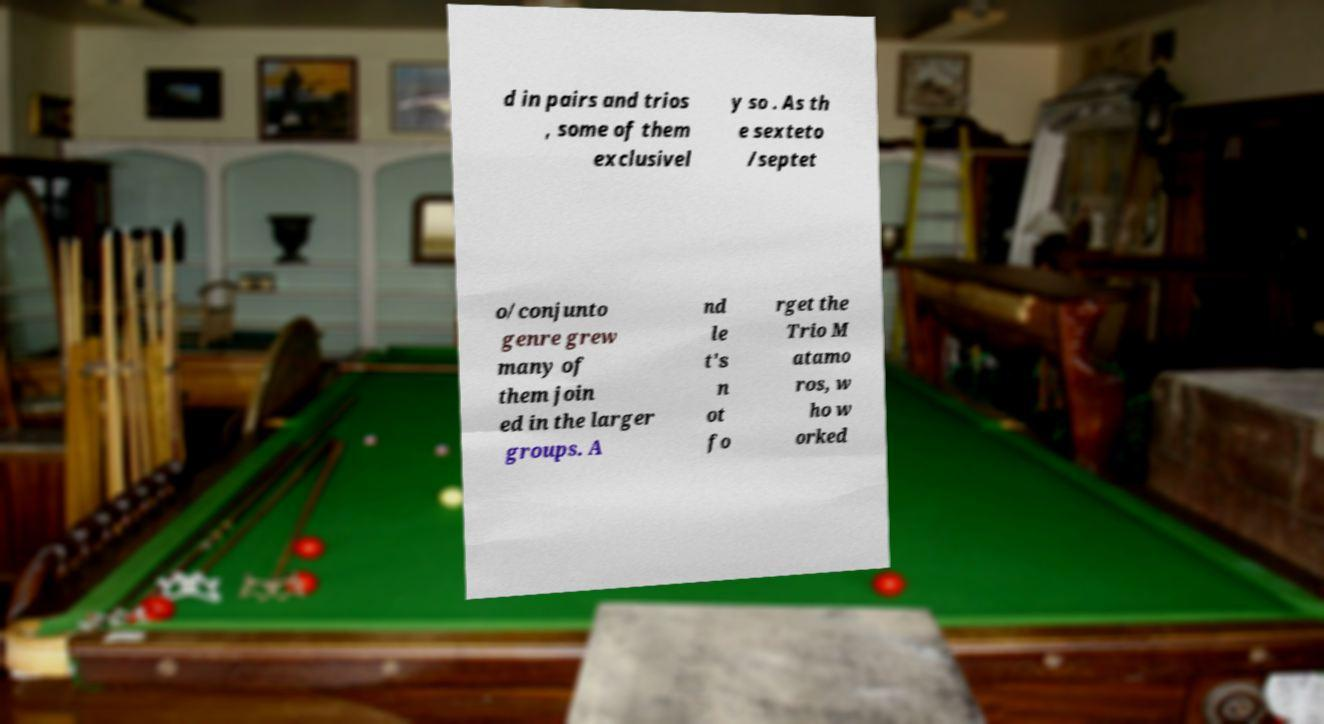I need the written content from this picture converted into text. Can you do that? d in pairs and trios , some of them exclusivel y so . As th e sexteto /septet o/conjunto genre grew many of them join ed in the larger groups. A nd le t's n ot fo rget the Trio M atamo ros, w ho w orked 